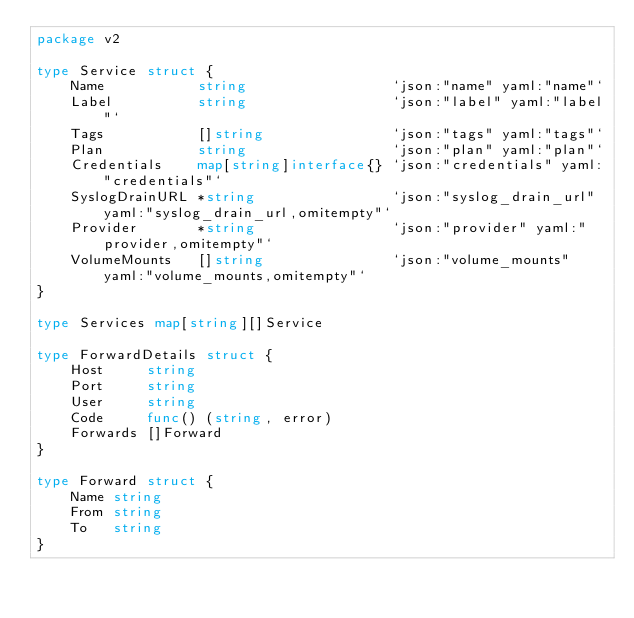<code> <loc_0><loc_0><loc_500><loc_500><_Go_>package v2

type Service struct {
	Name           string                 `json:"name" yaml:"name"`
	Label          string                 `json:"label" yaml:"label"`
	Tags           []string               `json:"tags" yaml:"tags"`
	Plan           string                 `json:"plan" yaml:"plan"`
	Credentials    map[string]interface{} `json:"credentials" yaml:"credentials"`
	SyslogDrainURL *string                `json:"syslog_drain_url" yaml:"syslog_drain_url,omitempty"`
	Provider       *string                `json:"provider" yaml:"provider,omitempty"`
	VolumeMounts   []string               `json:"volume_mounts" yaml:"volume_mounts,omitempty"`
}

type Services map[string][]Service

type ForwardDetails struct {
	Host     string
	Port     string
	User     string
	Code     func() (string, error)
	Forwards []Forward
}

type Forward struct {
	Name string
	From string
	To   string
}
</code> 